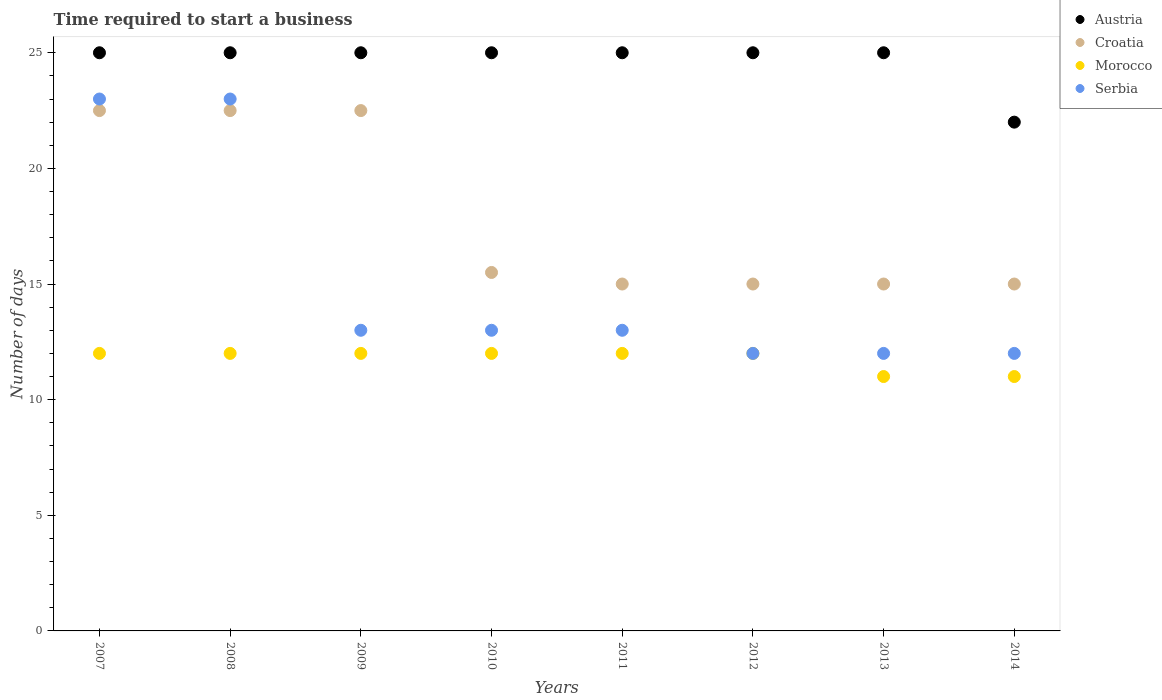Across all years, what is the maximum number of days required to start a business in Morocco?
Ensure brevity in your answer.  12. Across all years, what is the minimum number of days required to start a business in Austria?
Your response must be concise. 22. In which year was the number of days required to start a business in Morocco minimum?
Provide a succinct answer. 2013. What is the total number of days required to start a business in Croatia in the graph?
Your response must be concise. 143. What is the difference between the number of days required to start a business in Austria in 2008 and that in 2014?
Keep it short and to the point. 3. What is the difference between the number of days required to start a business in Croatia in 2011 and the number of days required to start a business in Austria in 2012?
Offer a terse response. -10. What is the average number of days required to start a business in Serbia per year?
Your answer should be very brief. 15.12. In the year 2014, what is the difference between the number of days required to start a business in Serbia and number of days required to start a business in Croatia?
Keep it short and to the point. -3. In how many years, is the number of days required to start a business in Morocco greater than 13 days?
Offer a terse response. 0. Is the difference between the number of days required to start a business in Serbia in 2008 and 2009 greater than the difference between the number of days required to start a business in Croatia in 2008 and 2009?
Your response must be concise. Yes. What is the difference between the highest and the second highest number of days required to start a business in Austria?
Your answer should be very brief. 0. In how many years, is the number of days required to start a business in Croatia greater than the average number of days required to start a business in Croatia taken over all years?
Provide a short and direct response. 3. Is the sum of the number of days required to start a business in Morocco in 2008 and 2009 greater than the maximum number of days required to start a business in Croatia across all years?
Offer a very short reply. Yes. Is the number of days required to start a business in Croatia strictly greater than the number of days required to start a business in Morocco over the years?
Give a very brief answer. Yes. How many dotlines are there?
Make the answer very short. 4. How many years are there in the graph?
Offer a very short reply. 8. What is the difference between two consecutive major ticks on the Y-axis?
Offer a very short reply. 5. What is the title of the graph?
Offer a terse response. Time required to start a business. What is the label or title of the X-axis?
Offer a very short reply. Years. What is the label or title of the Y-axis?
Offer a terse response. Number of days. What is the Number of days in Austria in 2007?
Your response must be concise. 25. What is the Number of days in Croatia in 2007?
Offer a terse response. 22.5. What is the Number of days in Austria in 2008?
Ensure brevity in your answer.  25. What is the Number of days in Croatia in 2008?
Provide a short and direct response. 22.5. What is the Number of days in Morocco in 2008?
Offer a terse response. 12. What is the Number of days in Serbia in 2008?
Keep it short and to the point. 23. What is the Number of days in Austria in 2009?
Provide a short and direct response. 25. What is the Number of days in Croatia in 2009?
Your response must be concise. 22.5. What is the Number of days in Croatia in 2010?
Provide a short and direct response. 15.5. What is the Number of days in Serbia in 2010?
Provide a short and direct response. 13. What is the Number of days in Croatia in 2011?
Your answer should be very brief. 15. What is the Number of days in Croatia in 2012?
Offer a terse response. 15. What is the Number of days in Morocco in 2012?
Your response must be concise. 12. What is the Number of days of Morocco in 2013?
Offer a terse response. 11. What is the Number of days of Serbia in 2013?
Offer a very short reply. 12. What is the Number of days in Austria in 2014?
Give a very brief answer. 22. What is the Number of days in Croatia in 2014?
Ensure brevity in your answer.  15. What is the Number of days of Serbia in 2014?
Provide a succinct answer. 12. Across all years, what is the maximum Number of days of Morocco?
Your answer should be very brief. 12. Across all years, what is the maximum Number of days in Serbia?
Give a very brief answer. 23. Across all years, what is the minimum Number of days in Morocco?
Your response must be concise. 11. Across all years, what is the minimum Number of days of Serbia?
Give a very brief answer. 12. What is the total Number of days of Austria in the graph?
Make the answer very short. 197. What is the total Number of days in Croatia in the graph?
Offer a very short reply. 143. What is the total Number of days of Morocco in the graph?
Give a very brief answer. 94. What is the total Number of days of Serbia in the graph?
Ensure brevity in your answer.  121. What is the difference between the Number of days in Austria in 2007 and that in 2008?
Provide a short and direct response. 0. What is the difference between the Number of days of Morocco in 2007 and that in 2008?
Your response must be concise. 0. What is the difference between the Number of days in Austria in 2007 and that in 2009?
Ensure brevity in your answer.  0. What is the difference between the Number of days of Croatia in 2007 and that in 2009?
Your answer should be very brief. 0. What is the difference between the Number of days of Morocco in 2007 and that in 2009?
Keep it short and to the point. 0. What is the difference between the Number of days in Austria in 2007 and that in 2010?
Make the answer very short. 0. What is the difference between the Number of days of Austria in 2007 and that in 2011?
Offer a terse response. 0. What is the difference between the Number of days in Croatia in 2007 and that in 2011?
Your answer should be compact. 7.5. What is the difference between the Number of days in Morocco in 2007 and that in 2011?
Offer a very short reply. 0. What is the difference between the Number of days of Austria in 2007 and that in 2012?
Your answer should be very brief. 0. What is the difference between the Number of days in Croatia in 2007 and that in 2012?
Your answer should be very brief. 7.5. What is the difference between the Number of days of Serbia in 2007 and that in 2012?
Provide a short and direct response. 11. What is the difference between the Number of days of Morocco in 2007 and that in 2013?
Keep it short and to the point. 1. What is the difference between the Number of days in Croatia in 2008 and that in 2009?
Offer a very short reply. 0. What is the difference between the Number of days in Austria in 2008 and that in 2010?
Offer a very short reply. 0. What is the difference between the Number of days in Morocco in 2008 and that in 2010?
Keep it short and to the point. 0. What is the difference between the Number of days in Serbia in 2008 and that in 2010?
Ensure brevity in your answer.  10. What is the difference between the Number of days in Austria in 2008 and that in 2011?
Offer a very short reply. 0. What is the difference between the Number of days of Morocco in 2008 and that in 2011?
Your response must be concise. 0. What is the difference between the Number of days in Serbia in 2008 and that in 2011?
Your answer should be very brief. 10. What is the difference between the Number of days in Austria in 2008 and that in 2012?
Make the answer very short. 0. What is the difference between the Number of days in Croatia in 2008 and that in 2012?
Your answer should be very brief. 7.5. What is the difference between the Number of days of Austria in 2009 and that in 2010?
Provide a short and direct response. 0. What is the difference between the Number of days in Croatia in 2009 and that in 2010?
Keep it short and to the point. 7. What is the difference between the Number of days of Morocco in 2009 and that in 2010?
Your answer should be very brief. 0. What is the difference between the Number of days in Serbia in 2009 and that in 2010?
Provide a short and direct response. 0. What is the difference between the Number of days of Austria in 2009 and that in 2011?
Make the answer very short. 0. What is the difference between the Number of days in Serbia in 2009 and that in 2011?
Keep it short and to the point. 0. What is the difference between the Number of days of Austria in 2009 and that in 2012?
Offer a very short reply. 0. What is the difference between the Number of days of Croatia in 2009 and that in 2012?
Your answer should be compact. 7.5. What is the difference between the Number of days of Austria in 2009 and that in 2013?
Provide a succinct answer. 0. What is the difference between the Number of days in Croatia in 2009 and that in 2013?
Offer a terse response. 7.5. What is the difference between the Number of days of Morocco in 2009 and that in 2013?
Offer a very short reply. 1. What is the difference between the Number of days in Austria in 2009 and that in 2014?
Provide a short and direct response. 3. What is the difference between the Number of days in Morocco in 2009 and that in 2014?
Make the answer very short. 1. What is the difference between the Number of days of Serbia in 2009 and that in 2014?
Ensure brevity in your answer.  1. What is the difference between the Number of days of Morocco in 2010 and that in 2011?
Your answer should be compact. 0. What is the difference between the Number of days in Serbia in 2010 and that in 2011?
Your response must be concise. 0. What is the difference between the Number of days of Morocco in 2010 and that in 2012?
Offer a very short reply. 0. What is the difference between the Number of days in Serbia in 2010 and that in 2012?
Give a very brief answer. 1. What is the difference between the Number of days of Austria in 2010 and that in 2013?
Your answer should be very brief. 0. What is the difference between the Number of days of Croatia in 2010 and that in 2013?
Your answer should be very brief. 0.5. What is the difference between the Number of days in Austria in 2010 and that in 2014?
Provide a succinct answer. 3. What is the difference between the Number of days of Croatia in 2010 and that in 2014?
Make the answer very short. 0.5. What is the difference between the Number of days in Serbia in 2010 and that in 2014?
Ensure brevity in your answer.  1. What is the difference between the Number of days in Austria in 2011 and that in 2012?
Provide a short and direct response. 0. What is the difference between the Number of days of Morocco in 2011 and that in 2012?
Provide a short and direct response. 0. What is the difference between the Number of days in Austria in 2011 and that in 2013?
Keep it short and to the point. 0. What is the difference between the Number of days in Austria in 2012 and that in 2013?
Your answer should be compact. 0. What is the difference between the Number of days in Croatia in 2012 and that in 2013?
Keep it short and to the point. 0. What is the difference between the Number of days in Morocco in 2012 and that in 2013?
Your answer should be compact. 1. What is the difference between the Number of days in Serbia in 2012 and that in 2013?
Give a very brief answer. 0. What is the difference between the Number of days in Serbia in 2012 and that in 2014?
Offer a very short reply. 0. What is the difference between the Number of days of Austria in 2013 and that in 2014?
Give a very brief answer. 3. What is the difference between the Number of days of Austria in 2007 and the Number of days of Croatia in 2008?
Offer a very short reply. 2.5. What is the difference between the Number of days of Austria in 2007 and the Number of days of Morocco in 2008?
Keep it short and to the point. 13. What is the difference between the Number of days in Austria in 2007 and the Number of days in Serbia in 2008?
Offer a very short reply. 2. What is the difference between the Number of days of Croatia in 2007 and the Number of days of Morocco in 2008?
Give a very brief answer. 10.5. What is the difference between the Number of days of Austria in 2007 and the Number of days of Croatia in 2009?
Keep it short and to the point. 2.5. What is the difference between the Number of days of Austria in 2007 and the Number of days of Morocco in 2009?
Provide a short and direct response. 13. What is the difference between the Number of days of Croatia in 2007 and the Number of days of Morocco in 2009?
Provide a succinct answer. 10.5. What is the difference between the Number of days in Austria in 2007 and the Number of days in Croatia in 2010?
Your answer should be very brief. 9.5. What is the difference between the Number of days of Austria in 2007 and the Number of days of Morocco in 2010?
Provide a succinct answer. 13. What is the difference between the Number of days in Croatia in 2007 and the Number of days in Morocco in 2010?
Make the answer very short. 10.5. What is the difference between the Number of days in Croatia in 2007 and the Number of days in Serbia in 2010?
Ensure brevity in your answer.  9.5. What is the difference between the Number of days in Austria in 2007 and the Number of days in Croatia in 2011?
Provide a succinct answer. 10. What is the difference between the Number of days in Austria in 2007 and the Number of days in Serbia in 2011?
Provide a succinct answer. 12. What is the difference between the Number of days in Croatia in 2007 and the Number of days in Serbia in 2011?
Ensure brevity in your answer.  9.5. What is the difference between the Number of days in Austria in 2007 and the Number of days in Croatia in 2012?
Offer a very short reply. 10. What is the difference between the Number of days of Austria in 2007 and the Number of days of Croatia in 2013?
Your answer should be compact. 10. What is the difference between the Number of days of Austria in 2007 and the Number of days of Morocco in 2013?
Offer a very short reply. 14. What is the difference between the Number of days in Croatia in 2007 and the Number of days in Morocco in 2013?
Give a very brief answer. 11.5. What is the difference between the Number of days of Croatia in 2007 and the Number of days of Serbia in 2013?
Make the answer very short. 10.5. What is the difference between the Number of days in Austria in 2007 and the Number of days in Morocco in 2014?
Your answer should be compact. 14. What is the difference between the Number of days in Croatia in 2007 and the Number of days in Serbia in 2014?
Ensure brevity in your answer.  10.5. What is the difference between the Number of days of Austria in 2008 and the Number of days of Croatia in 2009?
Make the answer very short. 2.5. What is the difference between the Number of days in Austria in 2008 and the Number of days in Morocco in 2009?
Give a very brief answer. 13. What is the difference between the Number of days in Austria in 2008 and the Number of days in Serbia in 2009?
Your answer should be very brief. 12. What is the difference between the Number of days in Austria in 2008 and the Number of days in Morocco in 2010?
Your response must be concise. 13. What is the difference between the Number of days of Morocco in 2008 and the Number of days of Serbia in 2010?
Keep it short and to the point. -1. What is the difference between the Number of days in Austria in 2008 and the Number of days in Croatia in 2011?
Provide a succinct answer. 10. What is the difference between the Number of days in Austria in 2008 and the Number of days in Morocco in 2011?
Provide a short and direct response. 13. What is the difference between the Number of days of Austria in 2008 and the Number of days of Serbia in 2011?
Your response must be concise. 12. What is the difference between the Number of days of Austria in 2008 and the Number of days of Croatia in 2012?
Provide a short and direct response. 10. What is the difference between the Number of days in Austria in 2008 and the Number of days in Morocco in 2012?
Ensure brevity in your answer.  13. What is the difference between the Number of days of Morocco in 2008 and the Number of days of Serbia in 2012?
Your answer should be very brief. 0. What is the difference between the Number of days of Austria in 2008 and the Number of days of Serbia in 2013?
Offer a terse response. 13. What is the difference between the Number of days in Morocco in 2008 and the Number of days in Serbia in 2013?
Make the answer very short. 0. What is the difference between the Number of days in Austria in 2008 and the Number of days in Croatia in 2014?
Offer a terse response. 10. What is the difference between the Number of days in Austria in 2008 and the Number of days in Morocco in 2014?
Provide a short and direct response. 14. What is the difference between the Number of days of Austria in 2008 and the Number of days of Serbia in 2014?
Your response must be concise. 13. What is the difference between the Number of days in Croatia in 2008 and the Number of days in Morocco in 2014?
Provide a succinct answer. 11.5. What is the difference between the Number of days of Croatia in 2008 and the Number of days of Serbia in 2014?
Your answer should be compact. 10.5. What is the difference between the Number of days of Morocco in 2008 and the Number of days of Serbia in 2014?
Keep it short and to the point. 0. What is the difference between the Number of days in Austria in 2009 and the Number of days in Morocco in 2011?
Make the answer very short. 13. What is the difference between the Number of days of Austria in 2009 and the Number of days of Serbia in 2011?
Your answer should be compact. 12. What is the difference between the Number of days of Croatia in 2009 and the Number of days of Morocco in 2011?
Your response must be concise. 10.5. What is the difference between the Number of days in Croatia in 2009 and the Number of days in Serbia in 2011?
Make the answer very short. 9.5. What is the difference between the Number of days of Austria in 2009 and the Number of days of Croatia in 2012?
Ensure brevity in your answer.  10. What is the difference between the Number of days of Austria in 2009 and the Number of days of Morocco in 2012?
Ensure brevity in your answer.  13. What is the difference between the Number of days of Austria in 2009 and the Number of days of Serbia in 2012?
Provide a succinct answer. 13. What is the difference between the Number of days of Croatia in 2009 and the Number of days of Morocco in 2012?
Provide a short and direct response. 10.5. What is the difference between the Number of days of Austria in 2009 and the Number of days of Croatia in 2013?
Offer a very short reply. 10. What is the difference between the Number of days in Austria in 2009 and the Number of days in Serbia in 2013?
Make the answer very short. 13. What is the difference between the Number of days of Morocco in 2009 and the Number of days of Serbia in 2013?
Keep it short and to the point. 0. What is the difference between the Number of days in Austria in 2009 and the Number of days in Serbia in 2014?
Make the answer very short. 13. What is the difference between the Number of days in Croatia in 2009 and the Number of days in Morocco in 2014?
Make the answer very short. 11.5. What is the difference between the Number of days of Austria in 2010 and the Number of days of Croatia in 2011?
Offer a very short reply. 10. What is the difference between the Number of days of Croatia in 2010 and the Number of days of Serbia in 2011?
Give a very brief answer. 2.5. What is the difference between the Number of days in Morocco in 2010 and the Number of days in Serbia in 2011?
Your response must be concise. -1. What is the difference between the Number of days of Austria in 2010 and the Number of days of Croatia in 2012?
Your answer should be compact. 10. What is the difference between the Number of days in Austria in 2010 and the Number of days in Morocco in 2012?
Your answer should be compact. 13. What is the difference between the Number of days in Croatia in 2010 and the Number of days in Morocco in 2012?
Ensure brevity in your answer.  3.5. What is the difference between the Number of days in Morocco in 2010 and the Number of days in Serbia in 2012?
Your answer should be compact. 0. What is the difference between the Number of days of Austria in 2010 and the Number of days of Morocco in 2013?
Your response must be concise. 14. What is the difference between the Number of days of Austria in 2010 and the Number of days of Serbia in 2013?
Ensure brevity in your answer.  13. What is the difference between the Number of days in Croatia in 2010 and the Number of days in Morocco in 2013?
Provide a succinct answer. 4.5. What is the difference between the Number of days in Croatia in 2010 and the Number of days in Serbia in 2013?
Give a very brief answer. 3.5. What is the difference between the Number of days in Morocco in 2010 and the Number of days in Serbia in 2013?
Give a very brief answer. 0. What is the difference between the Number of days of Croatia in 2010 and the Number of days of Serbia in 2014?
Offer a very short reply. 3.5. What is the difference between the Number of days in Morocco in 2010 and the Number of days in Serbia in 2014?
Give a very brief answer. 0. What is the difference between the Number of days in Austria in 2011 and the Number of days in Morocco in 2012?
Keep it short and to the point. 13. What is the difference between the Number of days in Austria in 2011 and the Number of days in Serbia in 2012?
Keep it short and to the point. 13. What is the difference between the Number of days in Croatia in 2011 and the Number of days in Morocco in 2012?
Ensure brevity in your answer.  3. What is the difference between the Number of days of Croatia in 2011 and the Number of days of Serbia in 2012?
Provide a short and direct response. 3. What is the difference between the Number of days of Morocco in 2011 and the Number of days of Serbia in 2012?
Keep it short and to the point. 0. What is the difference between the Number of days in Austria in 2011 and the Number of days in Morocco in 2013?
Offer a very short reply. 14. What is the difference between the Number of days in Austria in 2011 and the Number of days in Croatia in 2014?
Offer a terse response. 10. What is the difference between the Number of days of Austria in 2011 and the Number of days of Morocco in 2014?
Provide a short and direct response. 14. What is the difference between the Number of days in Croatia in 2011 and the Number of days in Morocco in 2014?
Offer a very short reply. 4. What is the difference between the Number of days in Croatia in 2011 and the Number of days in Serbia in 2014?
Your answer should be compact. 3. What is the difference between the Number of days of Morocco in 2011 and the Number of days of Serbia in 2014?
Ensure brevity in your answer.  0. What is the difference between the Number of days in Austria in 2012 and the Number of days in Croatia in 2013?
Provide a short and direct response. 10. What is the difference between the Number of days in Austria in 2012 and the Number of days in Morocco in 2013?
Make the answer very short. 14. What is the difference between the Number of days in Austria in 2012 and the Number of days in Serbia in 2013?
Offer a terse response. 13. What is the difference between the Number of days of Austria in 2012 and the Number of days of Croatia in 2014?
Your answer should be very brief. 10. What is the difference between the Number of days in Austria in 2012 and the Number of days in Morocco in 2014?
Provide a short and direct response. 14. What is the difference between the Number of days in Croatia in 2012 and the Number of days in Morocco in 2014?
Make the answer very short. 4. What is the difference between the Number of days in Morocco in 2012 and the Number of days in Serbia in 2014?
Keep it short and to the point. 0. What is the difference between the Number of days of Austria in 2013 and the Number of days of Croatia in 2014?
Ensure brevity in your answer.  10. What is the average Number of days in Austria per year?
Your response must be concise. 24.62. What is the average Number of days in Croatia per year?
Make the answer very short. 17.88. What is the average Number of days of Morocco per year?
Your answer should be very brief. 11.75. What is the average Number of days in Serbia per year?
Provide a succinct answer. 15.12. In the year 2007, what is the difference between the Number of days of Austria and Number of days of Croatia?
Provide a succinct answer. 2.5. In the year 2007, what is the difference between the Number of days of Austria and Number of days of Morocco?
Your answer should be very brief. 13. In the year 2007, what is the difference between the Number of days in Croatia and Number of days in Morocco?
Offer a very short reply. 10.5. In the year 2007, what is the difference between the Number of days of Morocco and Number of days of Serbia?
Your answer should be very brief. -11. In the year 2008, what is the difference between the Number of days of Austria and Number of days of Morocco?
Keep it short and to the point. 13. In the year 2008, what is the difference between the Number of days in Austria and Number of days in Serbia?
Offer a terse response. 2. In the year 2008, what is the difference between the Number of days of Croatia and Number of days of Morocco?
Provide a short and direct response. 10.5. In the year 2008, what is the difference between the Number of days of Croatia and Number of days of Serbia?
Make the answer very short. -0.5. In the year 2009, what is the difference between the Number of days in Austria and Number of days in Croatia?
Your response must be concise. 2.5. In the year 2009, what is the difference between the Number of days of Austria and Number of days of Serbia?
Your answer should be very brief. 12. In the year 2009, what is the difference between the Number of days of Croatia and Number of days of Morocco?
Offer a very short reply. 10.5. In the year 2010, what is the difference between the Number of days of Austria and Number of days of Croatia?
Provide a short and direct response. 9.5. In the year 2010, what is the difference between the Number of days in Austria and Number of days in Serbia?
Give a very brief answer. 12. In the year 2010, what is the difference between the Number of days in Croatia and Number of days in Morocco?
Give a very brief answer. 3.5. In the year 2010, what is the difference between the Number of days in Croatia and Number of days in Serbia?
Offer a terse response. 2.5. In the year 2011, what is the difference between the Number of days in Austria and Number of days in Croatia?
Provide a succinct answer. 10. In the year 2011, what is the difference between the Number of days in Croatia and Number of days in Morocco?
Your answer should be compact. 3. In the year 2011, what is the difference between the Number of days in Croatia and Number of days in Serbia?
Your response must be concise. 2. In the year 2011, what is the difference between the Number of days in Morocco and Number of days in Serbia?
Offer a terse response. -1. In the year 2012, what is the difference between the Number of days of Austria and Number of days of Morocco?
Make the answer very short. 13. In the year 2012, what is the difference between the Number of days of Croatia and Number of days of Morocco?
Provide a short and direct response. 3. In the year 2013, what is the difference between the Number of days of Austria and Number of days of Morocco?
Make the answer very short. 14. In the year 2013, what is the difference between the Number of days of Croatia and Number of days of Morocco?
Keep it short and to the point. 4. In the year 2013, what is the difference between the Number of days of Croatia and Number of days of Serbia?
Give a very brief answer. 3. In the year 2013, what is the difference between the Number of days in Morocco and Number of days in Serbia?
Your answer should be compact. -1. In the year 2014, what is the difference between the Number of days of Austria and Number of days of Croatia?
Offer a very short reply. 7. In the year 2014, what is the difference between the Number of days of Croatia and Number of days of Morocco?
Ensure brevity in your answer.  4. In the year 2014, what is the difference between the Number of days in Croatia and Number of days in Serbia?
Give a very brief answer. 3. What is the ratio of the Number of days of Austria in 2007 to that in 2008?
Offer a terse response. 1. What is the ratio of the Number of days of Croatia in 2007 to that in 2008?
Give a very brief answer. 1. What is the ratio of the Number of days of Austria in 2007 to that in 2009?
Your answer should be very brief. 1. What is the ratio of the Number of days of Croatia in 2007 to that in 2009?
Provide a succinct answer. 1. What is the ratio of the Number of days in Morocco in 2007 to that in 2009?
Your response must be concise. 1. What is the ratio of the Number of days of Serbia in 2007 to that in 2009?
Make the answer very short. 1.77. What is the ratio of the Number of days of Croatia in 2007 to that in 2010?
Offer a terse response. 1.45. What is the ratio of the Number of days of Serbia in 2007 to that in 2010?
Offer a very short reply. 1.77. What is the ratio of the Number of days of Austria in 2007 to that in 2011?
Keep it short and to the point. 1. What is the ratio of the Number of days in Serbia in 2007 to that in 2011?
Provide a succinct answer. 1.77. What is the ratio of the Number of days of Austria in 2007 to that in 2012?
Provide a short and direct response. 1. What is the ratio of the Number of days in Croatia in 2007 to that in 2012?
Provide a short and direct response. 1.5. What is the ratio of the Number of days in Morocco in 2007 to that in 2012?
Offer a very short reply. 1. What is the ratio of the Number of days in Serbia in 2007 to that in 2012?
Your response must be concise. 1.92. What is the ratio of the Number of days in Austria in 2007 to that in 2013?
Ensure brevity in your answer.  1. What is the ratio of the Number of days in Croatia in 2007 to that in 2013?
Offer a terse response. 1.5. What is the ratio of the Number of days in Serbia in 2007 to that in 2013?
Offer a very short reply. 1.92. What is the ratio of the Number of days in Austria in 2007 to that in 2014?
Give a very brief answer. 1.14. What is the ratio of the Number of days in Morocco in 2007 to that in 2014?
Make the answer very short. 1.09. What is the ratio of the Number of days of Serbia in 2007 to that in 2014?
Your answer should be very brief. 1.92. What is the ratio of the Number of days of Morocco in 2008 to that in 2009?
Make the answer very short. 1. What is the ratio of the Number of days of Serbia in 2008 to that in 2009?
Make the answer very short. 1.77. What is the ratio of the Number of days in Austria in 2008 to that in 2010?
Provide a short and direct response. 1. What is the ratio of the Number of days of Croatia in 2008 to that in 2010?
Ensure brevity in your answer.  1.45. What is the ratio of the Number of days of Morocco in 2008 to that in 2010?
Ensure brevity in your answer.  1. What is the ratio of the Number of days of Serbia in 2008 to that in 2010?
Your answer should be compact. 1.77. What is the ratio of the Number of days in Serbia in 2008 to that in 2011?
Ensure brevity in your answer.  1.77. What is the ratio of the Number of days in Austria in 2008 to that in 2012?
Ensure brevity in your answer.  1. What is the ratio of the Number of days of Croatia in 2008 to that in 2012?
Ensure brevity in your answer.  1.5. What is the ratio of the Number of days of Serbia in 2008 to that in 2012?
Your response must be concise. 1.92. What is the ratio of the Number of days of Croatia in 2008 to that in 2013?
Your answer should be very brief. 1.5. What is the ratio of the Number of days of Serbia in 2008 to that in 2013?
Provide a short and direct response. 1.92. What is the ratio of the Number of days in Austria in 2008 to that in 2014?
Keep it short and to the point. 1.14. What is the ratio of the Number of days of Croatia in 2008 to that in 2014?
Make the answer very short. 1.5. What is the ratio of the Number of days in Serbia in 2008 to that in 2014?
Your answer should be very brief. 1.92. What is the ratio of the Number of days in Croatia in 2009 to that in 2010?
Give a very brief answer. 1.45. What is the ratio of the Number of days of Morocco in 2009 to that in 2011?
Offer a very short reply. 1. What is the ratio of the Number of days in Morocco in 2009 to that in 2012?
Offer a terse response. 1. What is the ratio of the Number of days of Serbia in 2009 to that in 2012?
Provide a succinct answer. 1.08. What is the ratio of the Number of days in Austria in 2009 to that in 2013?
Your answer should be very brief. 1. What is the ratio of the Number of days in Croatia in 2009 to that in 2013?
Offer a very short reply. 1.5. What is the ratio of the Number of days in Serbia in 2009 to that in 2013?
Provide a short and direct response. 1.08. What is the ratio of the Number of days of Austria in 2009 to that in 2014?
Keep it short and to the point. 1.14. What is the ratio of the Number of days in Morocco in 2010 to that in 2011?
Your answer should be compact. 1. What is the ratio of the Number of days in Serbia in 2010 to that in 2011?
Your answer should be compact. 1. What is the ratio of the Number of days in Croatia in 2010 to that in 2012?
Provide a succinct answer. 1.03. What is the ratio of the Number of days of Serbia in 2010 to that in 2012?
Ensure brevity in your answer.  1.08. What is the ratio of the Number of days of Croatia in 2010 to that in 2013?
Your response must be concise. 1.03. What is the ratio of the Number of days in Morocco in 2010 to that in 2013?
Provide a succinct answer. 1.09. What is the ratio of the Number of days of Austria in 2010 to that in 2014?
Your answer should be very brief. 1.14. What is the ratio of the Number of days of Austria in 2011 to that in 2012?
Offer a terse response. 1. What is the ratio of the Number of days of Serbia in 2011 to that in 2012?
Offer a very short reply. 1.08. What is the ratio of the Number of days in Austria in 2011 to that in 2013?
Offer a terse response. 1. What is the ratio of the Number of days of Austria in 2011 to that in 2014?
Provide a short and direct response. 1.14. What is the ratio of the Number of days of Croatia in 2011 to that in 2014?
Your response must be concise. 1. What is the ratio of the Number of days of Morocco in 2011 to that in 2014?
Ensure brevity in your answer.  1.09. What is the ratio of the Number of days of Austria in 2012 to that in 2013?
Offer a very short reply. 1. What is the ratio of the Number of days of Croatia in 2012 to that in 2013?
Keep it short and to the point. 1. What is the ratio of the Number of days of Morocco in 2012 to that in 2013?
Your answer should be very brief. 1.09. What is the ratio of the Number of days of Austria in 2012 to that in 2014?
Make the answer very short. 1.14. What is the ratio of the Number of days of Croatia in 2012 to that in 2014?
Give a very brief answer. 1. What is the ratio of the Number of days of Morocco in 2012 to that in 2014?
Ensure brevity in your answer.  1.09. What is the ratio of the Number of days of Serbia in 2012 to that in 2014?
Your response must be concise. 1. What is the ratio of the Number of days in Austria in 2013 to that in 2014?
Provide a succinct answer. 1.14. What is the ratio of the Number of days of Morocco in 2013 to that in 2014?
Offer a terse response. 1. What is the ratio of the Number of days of Serbia in 2013 to that in 2014?
Offer a terse response. 1. What is the difference between the highest and the second highest Number of days of Austria?
Give a very brief answer. 0. What is the difference between the highest and the second highest Number of days of Croatia?
Your answer should be compact. 0. What is the difference between the highest and the second highest Number of days of Morocco?
Provide a succinct answer. 0. What is the difference between the highest and the second highest Number of days in Serbia?
Offer a terse response. 0. What is the difference between the highest and the lowest Number of days of Austria?
Make the answer very short. 3. What is the difference between the highest and the lowest Number of days in Croatia?
Ensure brevity in your answer.  7.5. 